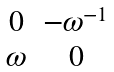Convert formula to latex. <formula><loc_0><loc_0><loc_500><loc_500>\begin{matrix} 0 & - \omega ^ { - 1 } \\ \omega & 0 \end{matrix}</formula> 